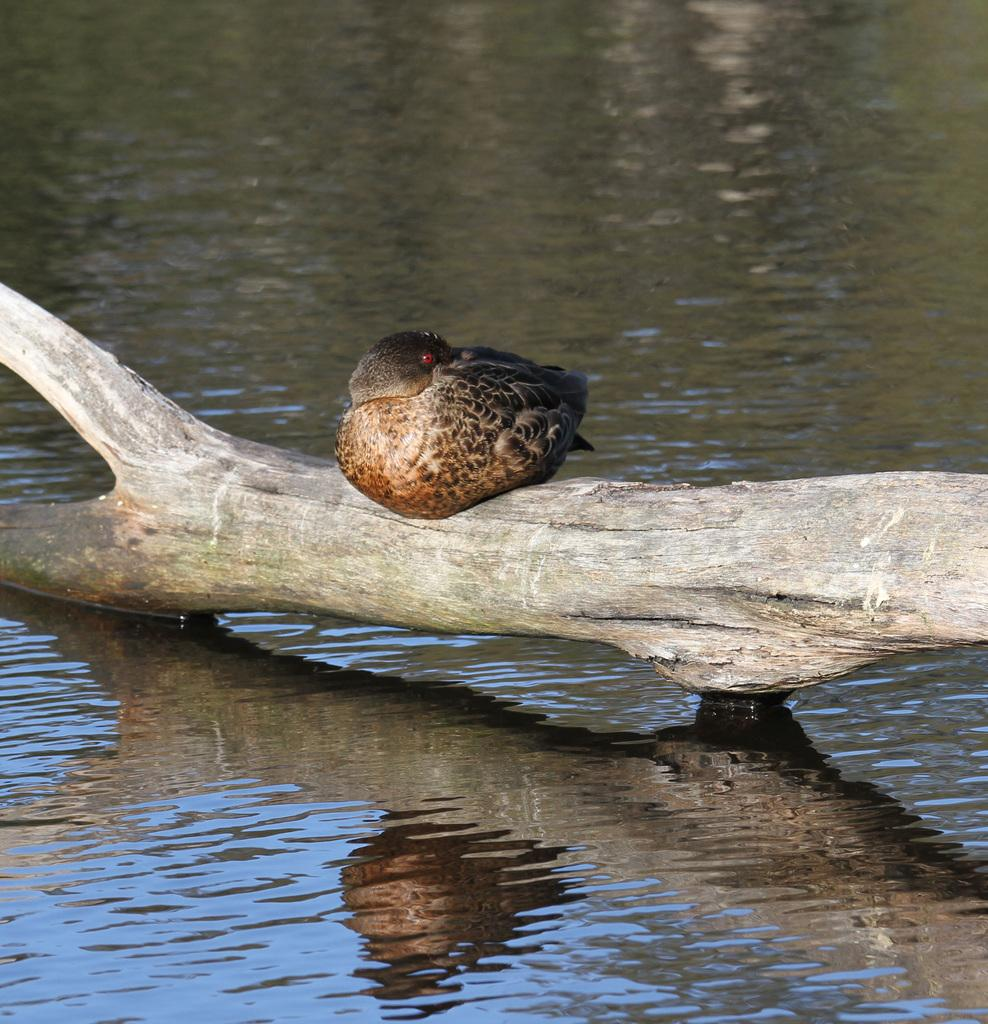What type of animal is in the image? There is a bird in the image. Where is the bird located? The bird is on a trunk in the image. What else can be seen in the image besides the bird? There is water visible in the image. What time of day is it in the image? The time of day is not mentioned in the image, so it cannot be determined. 